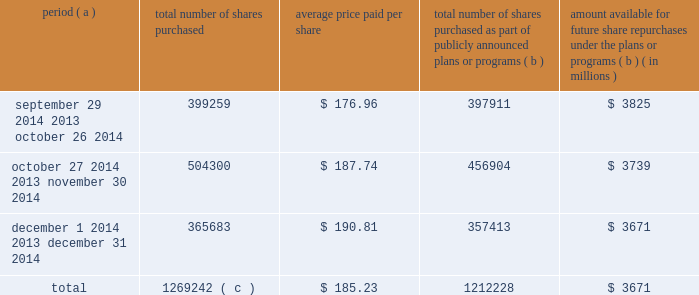Purchases of equity securities the table provides information about our repurchases of our common stock registered pursuant to section 12 of the securities exchange act of 1934 during the quarter ended december 31 , 2014 .
Period ( a ) number of shares purchased average price paid per share total number of shares purchased as part of publicly announced plans or programs ( b ) amount available for future share repurchases under the plans or programs ( b ) ( in millions ) .
Total 1269242 ( c ) $ 185.23 1212228 $ 3671 ( a ) we close our books and records on the last sunday of each month to align our financial closing with our business processes , except for the month of december , as our fiscal year ends on december 31 .
As a result , our fiscal months often differ from the calendar months .
For example , september 29 , 2014 was the first day of our october 2014 fiscal month .
( b ) in october 2010 , our board of directors approved a share repurchase program pursuant to which we are authorized to repurchase our common stock in privately negotiated transactions or in the open market at prices per share not exceeding the then-current market prices .
On september 25 , 2014 , our board of directors authorized a $ 2.0 billion increase to the program .
Under the program , management has discretion to determine the dollar amount of shares to be repurchased and the timing of any repurchases in compliance with applicable law and regulation .
We also may make purchases under the program pursuant to rule 10b5-1 plans .
The program does not have an expiration date .
( c ) during the quarter ended december 31 , 2014 , the total number of shares purchased included 57014 shares that were transferred to us by employees in satisfaction of minimum tax withholding obligations associated with the vesting of restricted stock units .
These purchases were made pursuant to a separate authorization by our board of directors and are not included within the program. .
What is the growth rate in the average price of the purchased shares from october to december 2014? 
Computations: ((190.81 - 176.96) / 176.96)
Answer: 0.07827. 